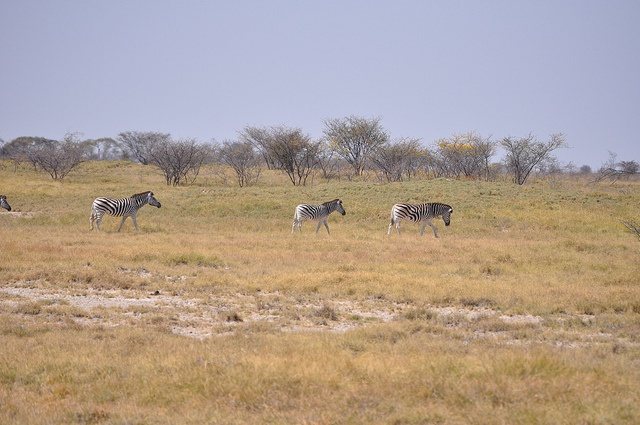Describe the objects in this image and their specific colors. I can see zebra in darkgray, tan, gray, and black tones, zebra in darkgray, gray, tan, and black tones, zebra in darkgray, gray, and tan tones, and zebra in darkgray, gray, and black tones in this image. 